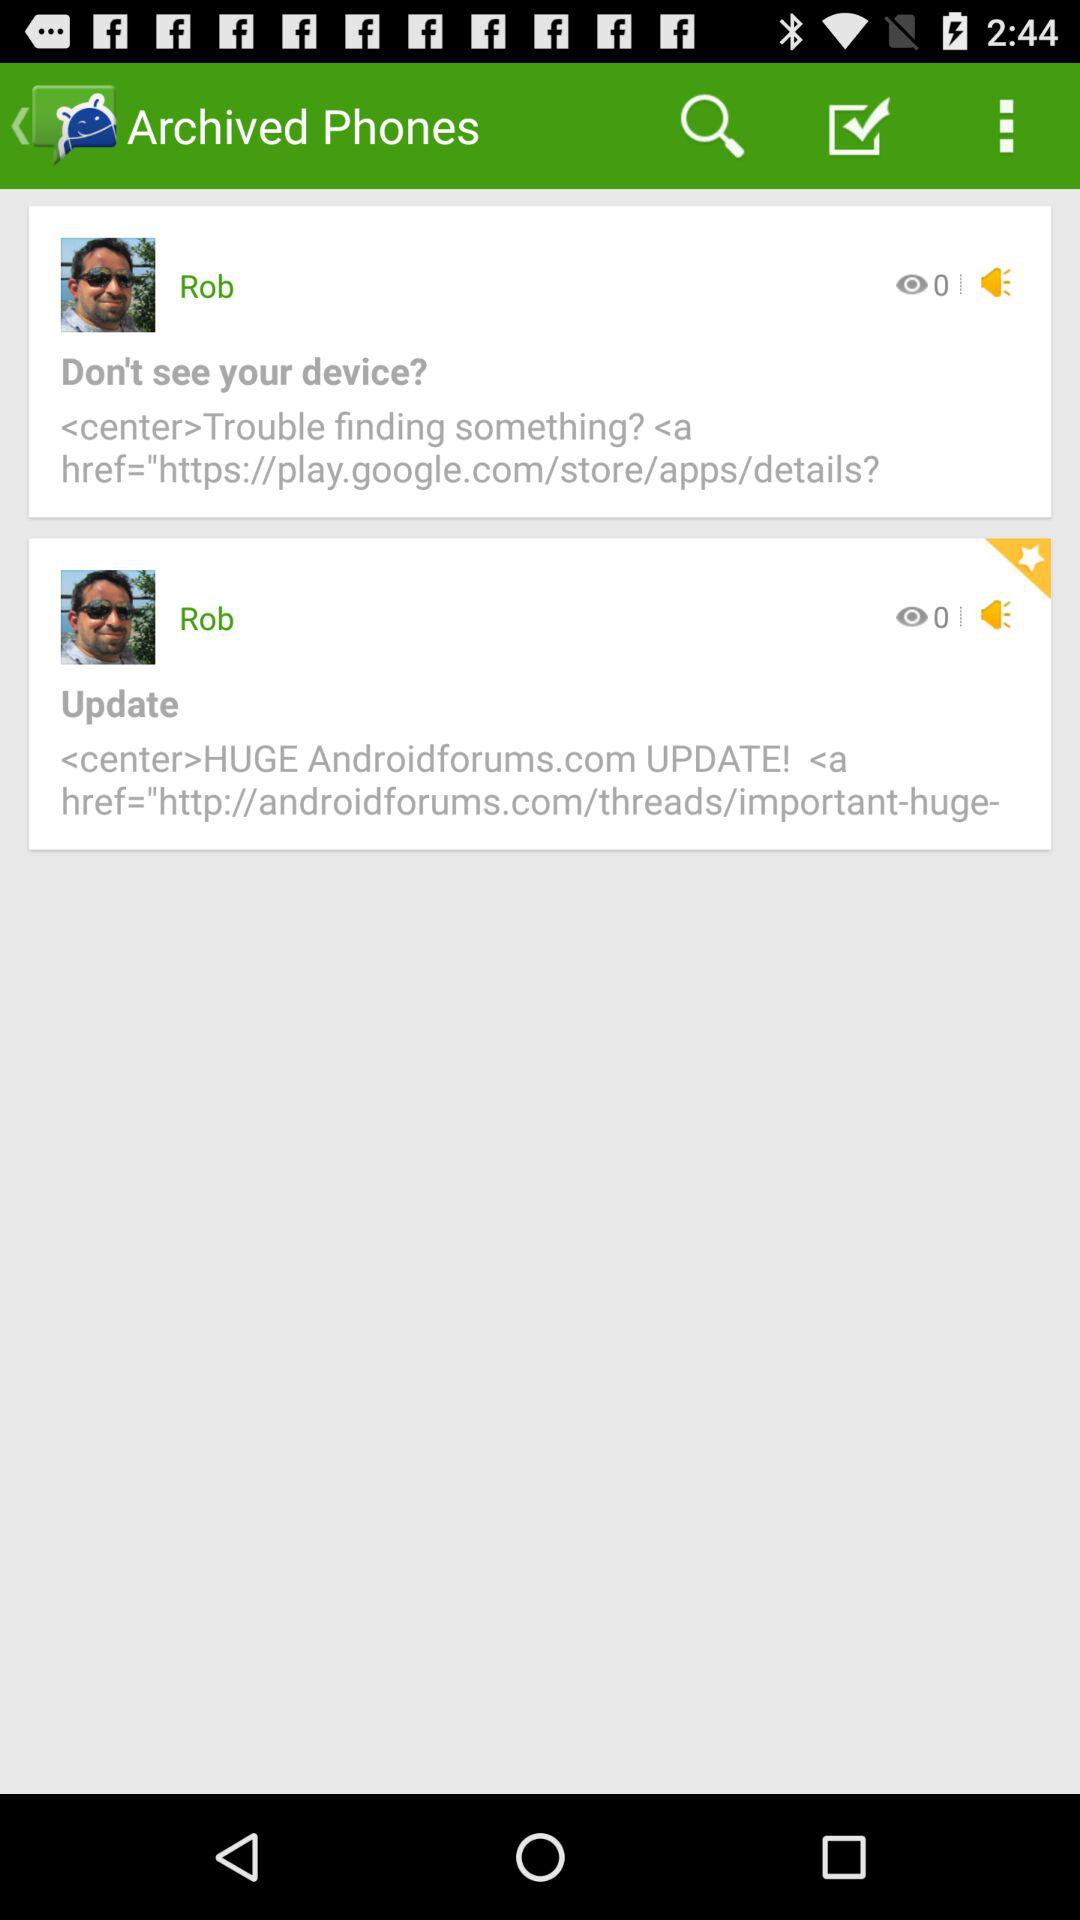How many items have the text 'Rob'?
Answer the question using a single word or phrase. 2 